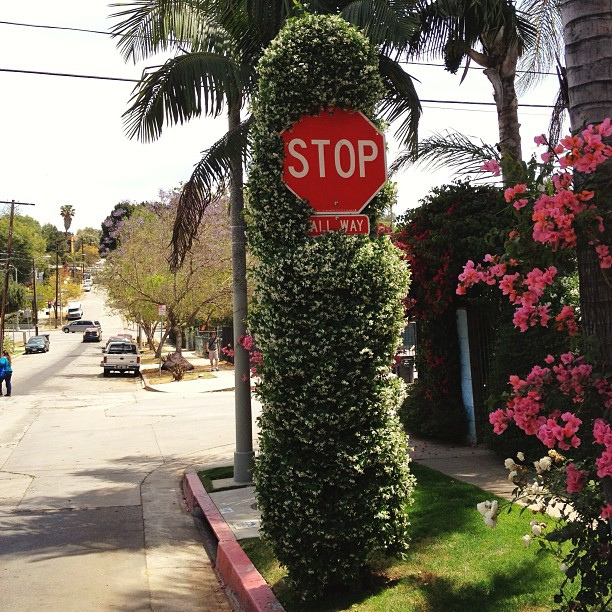Identify and read out the text in this image. STOP ALL WAY 